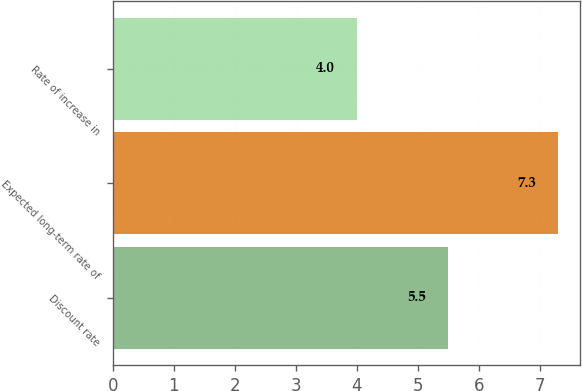Convert chart to OTSL. <chart><loc_0><loc_0><loc_500><loc_500><bar_chart><fcel>Discount rate<fcel>Expected long-term rate of<fcel>Rate of increase in<nl><fcel>5.5<fcel>7.3<fcel>4<nl></chart> 